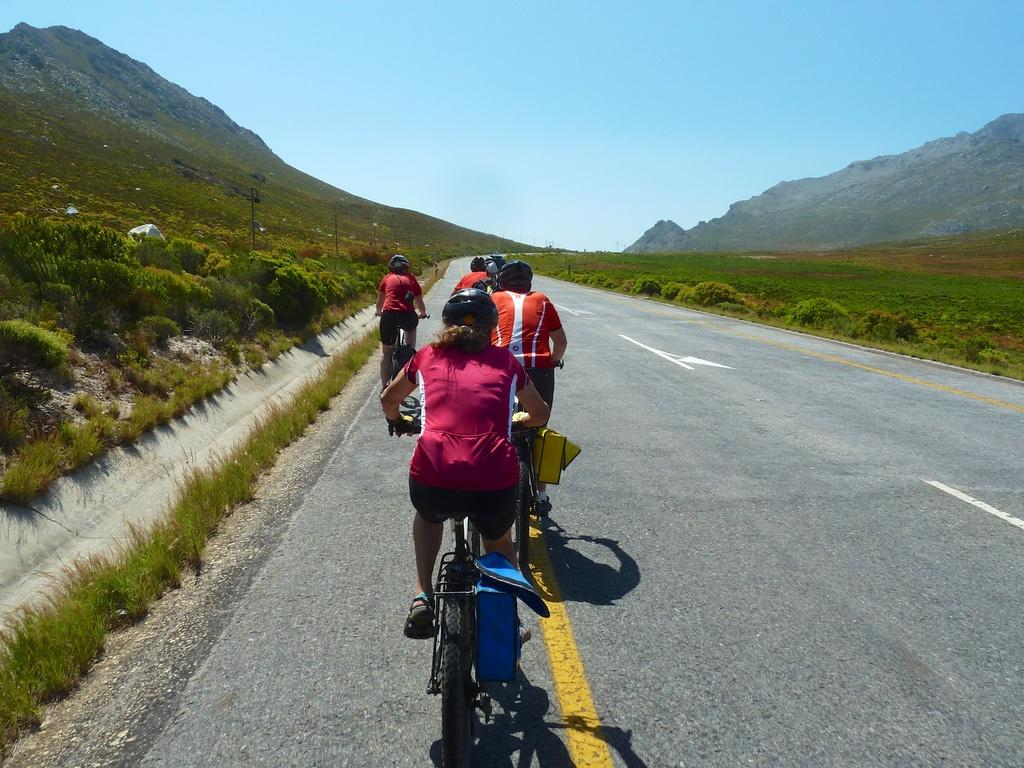How many people are in the image? There is a group of people in the image. What are the people wearing on their heads? The people are wearing helmets. What activity are the people engaged in? The people are cycling on the road. What type of vegetation can be seen in the image? There are plants and grass visible in the image. What structures can be seen in the image? There are poles in the image. What geographical feature is visible in the background of the image? The mountains are visible in the image. What is the weather like in the image? The sky is cloudy in the image. What type of popcorn is being served during the discussion in the image? There is no discussion or popcorn present in the image; it features a group of people cycling on the road. 